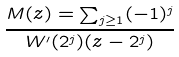<formula> <loc_0><loc_0><loc_500><loc_500>\frac { M ( z ) = \sum _ { j \geq 1 } ( - 1 ) ^ { j } } { W ^ { \prime } ( 2 ^ { j } ) ( z - 2 ^ { j } ) }</formula> 